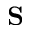Convert formula to latex. <formula><loc_0><loc_0><loc_500><loc_500>S</formula> 